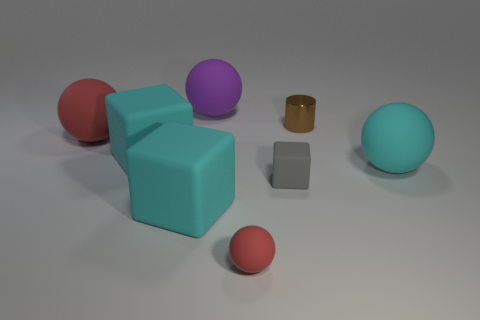Add 1 red balls. How many objects exist? 9 Subtract all blocks. How many objects are left? 5 Subtract all large cyan cubes. Subtract all big red things. How many objects are left? 5 Add 1 tiny red balls. How many tiny red balls are left? 2 Add 3 tiny brown cylinders. How many tiny brown cylinders exist? 4 Subtract 0 blue blocks. How many objects are left? 8 